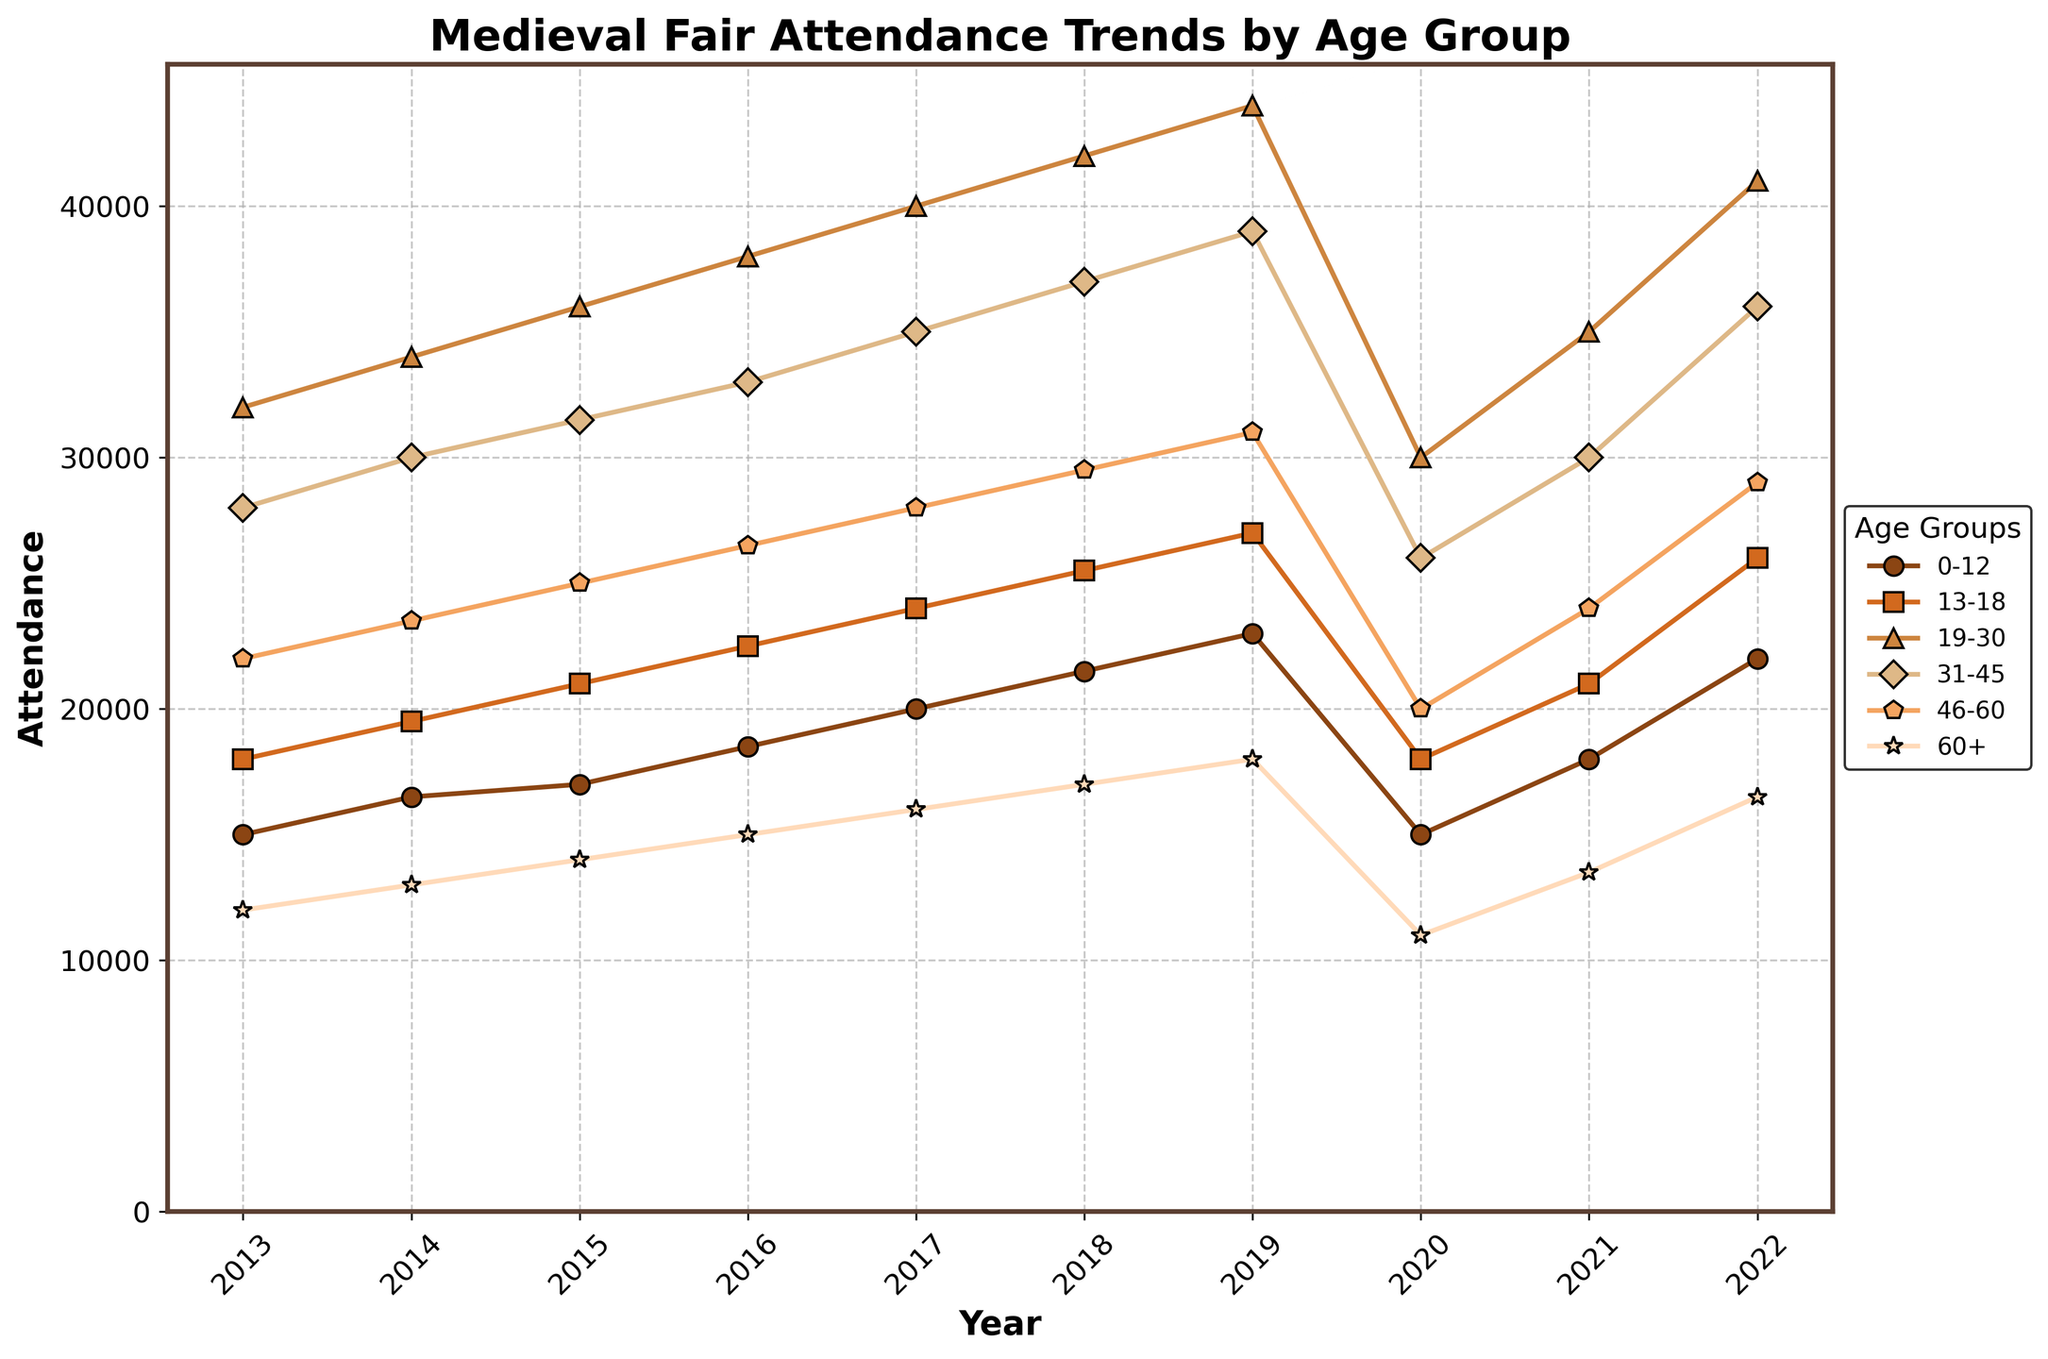What was the trend in attendance for the 19-30 age group throughout the decade? Looking at the line for the 19-30 age group, we see a general upward trend from 32,000 in 2013 to a peak at 44,000 in 2019, followed by a slight dip in 2020 and a recovery in subsequent years.
Answer: Upward trend Which year saw the lowest overall attendance across all age groups? To determine the lowest overall attendance year, we check the lines for all age groups. Year 2020 shows a clear drop for every age group compared to other years, indicating the lowest overall attendance.
Answer: 2020 How did the attendance for the 31-45 age group change from 2013 to 2022? In 2013, the attendance was 28,000 for the 31-45 age group. By 2022, it increased to 36,000. Calculating the difference: 36,000 - 28,000 = 8,000 increase.
Answer: Increased by 8,000 Which age group had the highest attendance in 2017? By examining the lines at the 2017 point, the 19-30 age group had the highest attendance with 40,000 attendees.
Answer: 19-30 Compare the attendance trends of the 0-12 and the 60+ age groups. Which one grew more over the decade? For the 0-12 age group, attendance goes from 15,000 in 2013 to 22,000 in 2022, an increase of 7,000. For the 60+ age group, it goes from 12,000 in 2013 to 16,500 in 2022, an increase of 4,500. Thus, the 0-12 age group grew more.
Answer: 0-12 grew more What is the average attendance for the 46-60 age group from 2013 to 2022? Sum up the yearly attendances: 22,000 + 23,500 + 25,000 + 26,500 + 28,000 + 29,500 + 31,000 + 20,000 + 24,000 + 29,000 = 259,500. Divide by the number of years: 259,500 / 10 = 25,950.
Answer: 25,950 Which age group showed the most significant drop in attendance between 2019 and 2020? Checking the values for 2019 and 2020, the age group 19-30 dropped from 44,000 to 30,000. Calculating the drop: 44,000 - 30,000 = 14,000, which is the most significant drop among all age groups.
Answer: 19-30 In which year did the 13-18 age group surpass the 31-45 age group in attendance? Observing the trend lines, the 13-18 age group surpassed the 31-45 age group starting in 2021, with attendances of 21,000 (13-18) and 30,000 (31-45). In 2021, 26,000 (13-18) is higher than 36,000 (31-45).
Answer: 2021 During which year did the 0-12 age group have the same attendance as the 60+ age group? Lines for the 0-12 and 60+ age groups intersect in 2020, where both age groups had an attendance of 15,000.
Answer: 2020 